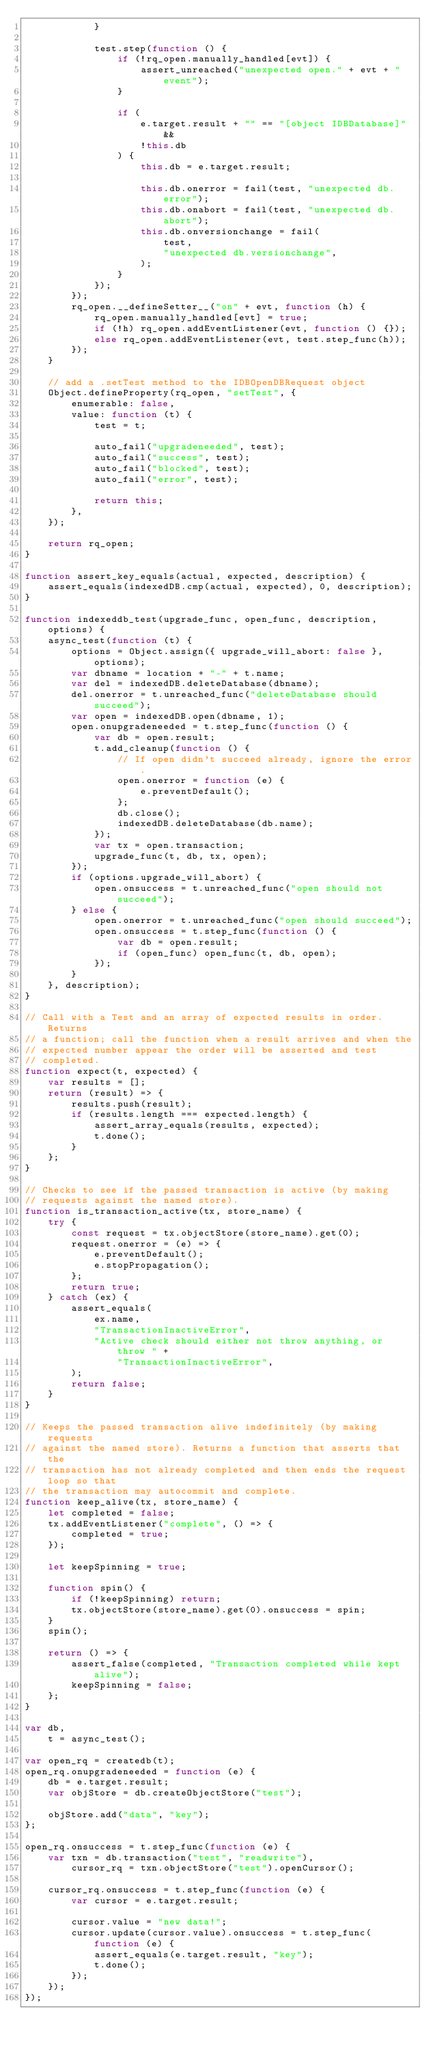Convert code to text. <code><loc_0><loc_0><loc_500><loc_500><_JavaScript_>            }

            test.step(function () {
                if (!rq_open.manually_handled[evt]) {
                    assert_unreached("unexpected open." + evt + " event");
                }

                if (
                    e.target.result + "" == "[object IDBDatabase]" &&
                    !this.db
                ) {
                    this.db = e.target.result;

                    this.db.onerror = fail(test, "unexpected db.error");
                    this.db.onabort = fail(test, "unexpected db.abort");
                    this.db.onversionchange = fail(
                        test,
                        "unexpected db.versionchange",
                    );
                }
            });
        });
        rq_open.__defineSetter__("on" + evt, function (h) {
            rq_open.manually_handled[evt] = true;
            if (!h) rq_open.addEventListener(evt, function () {});
            else rq_open.addEventListener(evt, test.step_func(h));
        });
    }

    // add a .setTest method to the IDBOpenDBRequest object
    Object.defineProperty(rq_open, "setTest", {
        enumerable: false,
        value: function (t) {
            test = t;

            auto_fail("upgradeneeded", test);
            auto_fail("success", test);
            auto_fail("blocked", test);
            auto_fail("error", test);

            return this;
        },
    });

    return rq_open;
}

function assert_key_equals(actual, expected, description) {
    assert_equals(indexedDB.cmp(actual, expected), 0, description);
}

function indexeddb_test(upgrade_func, open_func, description, options) {
    async_test(function (t) {
        options = Object.assign({ upgrade_will_abort: false }, options);
        var dbname = location + "-" + t.name;
        var del = indexedDB.deleteDatabase(dbname);
        del.onerror = t.unreached_func("deleteDatabase should succeed");
        var open = indexedDB.open(dbname, 1);
        open.onupgradeneeded = t.step_func(function () {
            var db = open.result;
            t.add_cleanup(function () {
                // If open didn't succeed already, ignore the error.
                open.onerror = function (e) {
                    e.preventDefault();
                };
                db.close();
                indexedDB.deleteDatabase(db.name);
            });
            var tx = open.transaction;
            upgrade_func(t, db, tx, open);
        });
        if (options.upgrade_will_abort) {
            open.onsuccess = t.unreached_func("open should not succeed");
        } else {
            open.onerror = t.unreached_func("open should succeed");
            open.onsuccess = t.step_func(function () {
                var db = open.result;
                if (open_func) open_func(t, db, open);
            });
        }
    }, description);
}

// Call with a Test and an array of expected results in order. Returns
// a function; call the function when a result arrives and when the
// expected number appear the order will be asserted and test
// completed.
function expect(t, expected) {
    var results = [];
    return (result) => {
        results.push(result);
        if (results.length === expected.length) {
            assert_array_equals(results, expected);
            t.done();
        }
    };
}

// Checks to see if the passed transaction is active (by making
// requests against the named store).
function is_transaction_active(tx, store_name) {
    try {
        const request = tx.objectStore(store_name).get(0);
        request.onerror = (e) => {
            e.preventDefault();
            e.stopPropagation();
        };
        return true;
    } catch (ex) {
        assert_equals(
            ex.name,
            "TransactionInactiveError",
            "Active check should either not throw anything, or throw " +
                "TransactionInactiveError",
        );
        return false;
    }
}

// Keeps the passed transaction alive indefinitely (by making requests
// against the named store). Returns a function that asserts that the
// transaction has not already completed and then ends the request loop so that
// the transaction may autocommit and complete.
function keep_alive(tx, store_name) {
    let completed = false;
    tx.addEventListener("complete", () => {
        completed = true;
    });

    let keepSpinning = true;

    function spin() {
        if (!keepSpinning) return;
        tx.objectStore(store_name).get(0).onsuccess = spin;
    }
    spin();

    return () => {
        assert_false(completed, "Transaction completed while kept alive");
        keepSpinning = false;
    };
}

var db,
    t = async_test();

var open_rq = createdb(t);
open_rq.onupgradeneeded = function (e) {
    db = e.target.result;
    var objStore = db.createObjectStore("test");

    objStore.add("data", "key");
};

open_rq.onsuccess = t.step_func(function (e) {
    var txn = db.transaction("test", "readwrite"),
        cursor_rq = txn.objectStore("test").openCursor();

    cursor_rq.onsuccess = t.step_func(function (e) {
        var cursor = e.target.result;

        cursor.value = "new data!";
        cursor.update(cursor.value).onsuccess = t.step_func(function (e) {
            assert_equals(e.target.result, "key");
            t.done();
        });
    });
});
</code> 